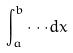Convert formula to latex. <formula><loc_0><loc_0><loc_500><loc_500>\int _ { a } ^ { b } \cdot \cdot \cdot d x</formula> 